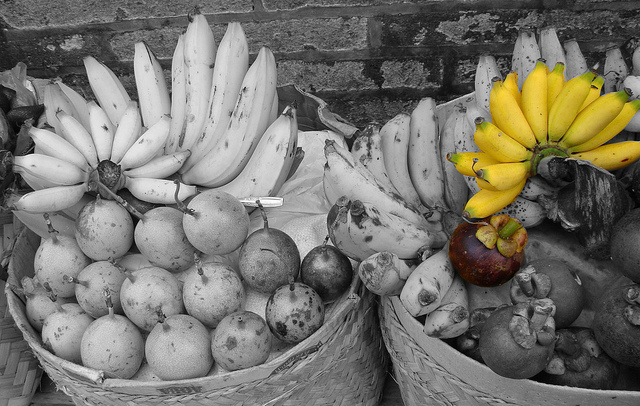Please provide a short description for this region: [0.26, 0.19, 0.47, 0.52]. One white banana oriented upwards. 